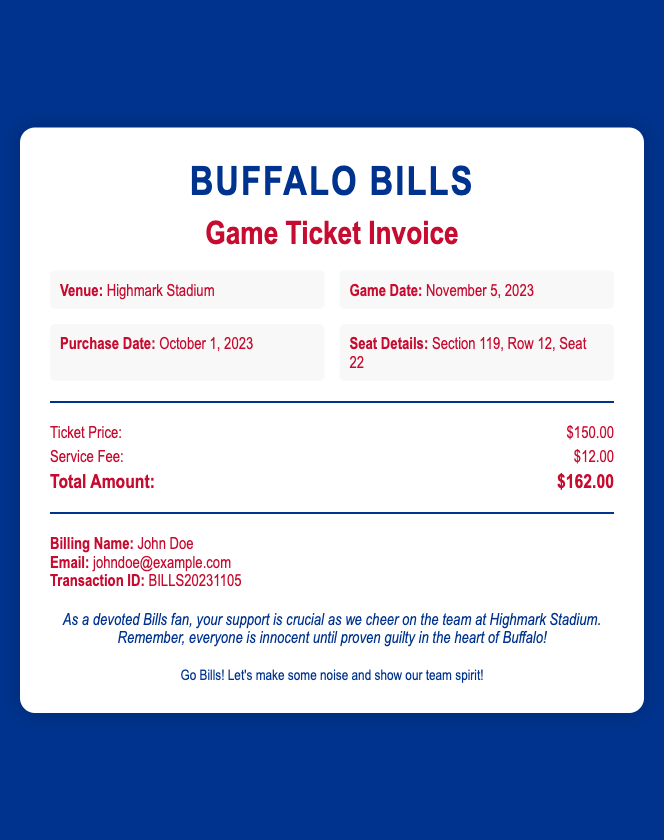What is the venue for the game? The venue is where the event is held, which is mentioned in the details section.
Answer: Highmark Stadium What is the game date? The game date is the scheduled date for the event, found in the details section.
Answer: November 5, 2023 What is the purchase date? The purchase date refers to when the ticket was bought, as listed in the details section.
Answer: October 1, 2023 Where is the seat located? Seat location includes the section, row, and seat number, all provided in the details.
Answer: Section 119, Row 12, Seat 22 What is the ticket price? The ticket price is specifically mentioned in the pricing section of the document.
Answer: $150.00 What is the total amount due? The total amount due is the sum of the ticket price and service fee, displayed prominently in the pricing section.
Answer: $162.00 What might the notes section imply? Notes provide a message related to the Bills fan spirit, suggesting the team's importance and a perspective on innocence.
Answer: Team support is crucial Who is the billing name? The billing name identifies the person who purchased the ticket, as mentioned in the document.
Answer: John Doe What does "Go Bills!" signify? "Go Bills!" is a cheer that expresses enthusiasm and support for the Buffalo Bills, indicated in the footer.
Answer: Team spirit 